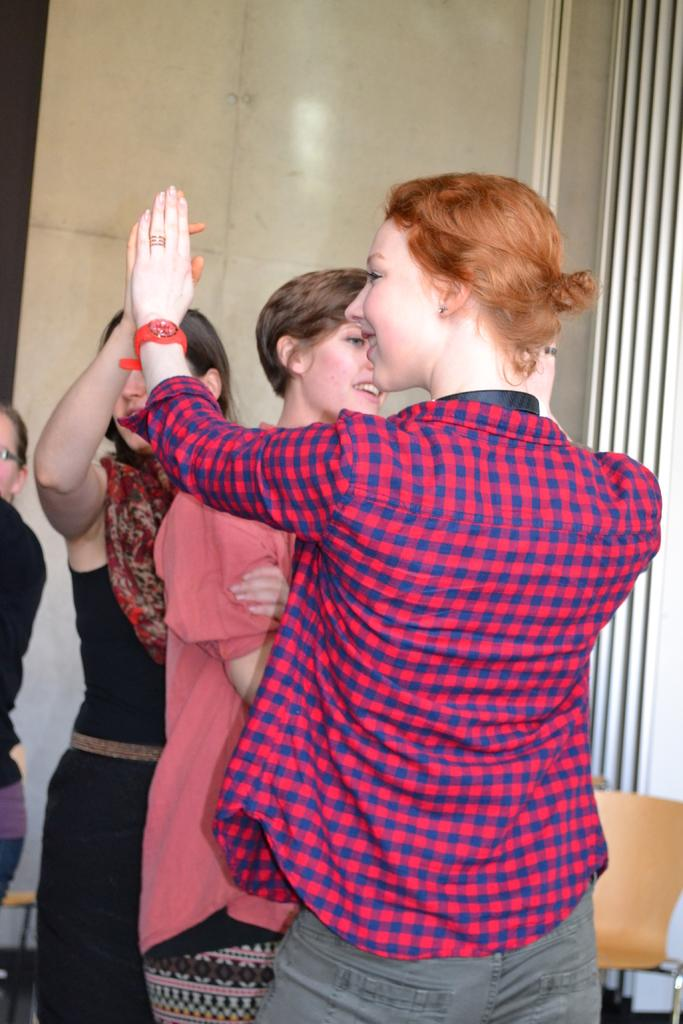What are the two women in the image doing? The two women are holding hands in the image. Is there anyone else between the two women? Yes, there is a third woman between the two women. Can you describe the person in the left corner of the image? Unfortunately, the facts provided do not give any information about the person in the left corner of the image. What type of duck can be seen swimming in the water in the image? There is no duck or water present in the image; it features two women holding hands and a third woman between them. 